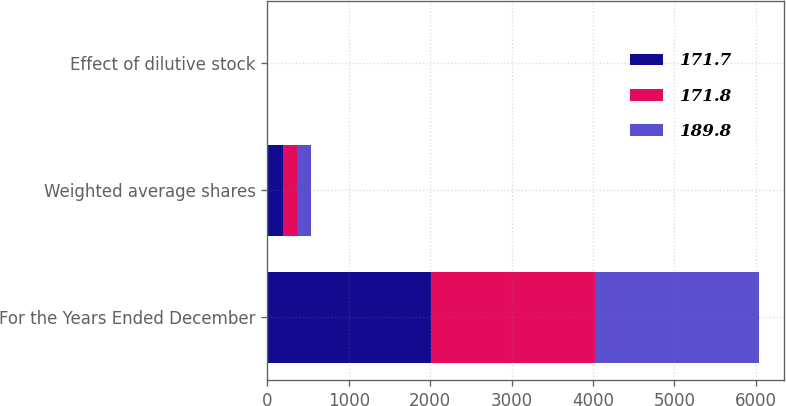Convert chart to OTSL. <chart><loc_0><loc_0><loc_500><loc_500><stacked_bar_chart><ecel><fcel>For the Years Ended December<fcel>Weighted average shares<fcel>Effect of dilutive stock<nl><fcel>171.7<fcel>2015<fcel>189.8<fcel>2.4<nl><fcel>171.8<fcel>2014<fcel>171.7<fcel>2.7<nl><fcel>189.8<fcel>2013<fcel>171.8<fcel>2.2<nl></chart> 